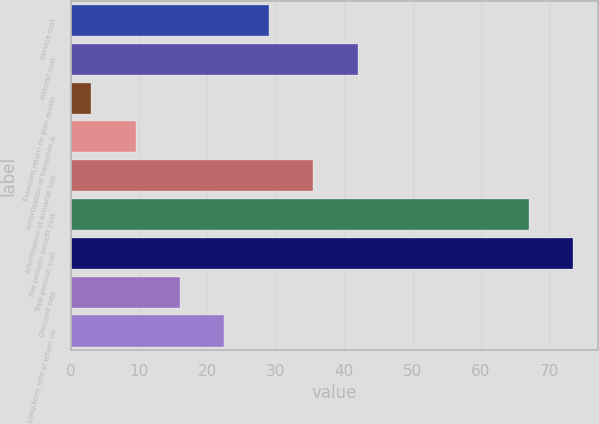Convert chart to OTSL. <chart><loc_0><loc_0><loc_500><loc_500><bar_chart><fcel>Service cost<fcel>Interest cost<fcel>Expected return on plan assets<fcel>Amortization of transition &<fcel>Amortization of actuarial loss<fcel>Net periodic benefit cost<fcel>Total pension cost<fcel>Discount rate<fcel>Long-term rate of return on<nl><fcel>29<fcel>42<fcel>3<fcel>9.5<fcel>35.5<fcel>67<fcel>73.5<fcel>16<fcel>22.5<nl></chart> 